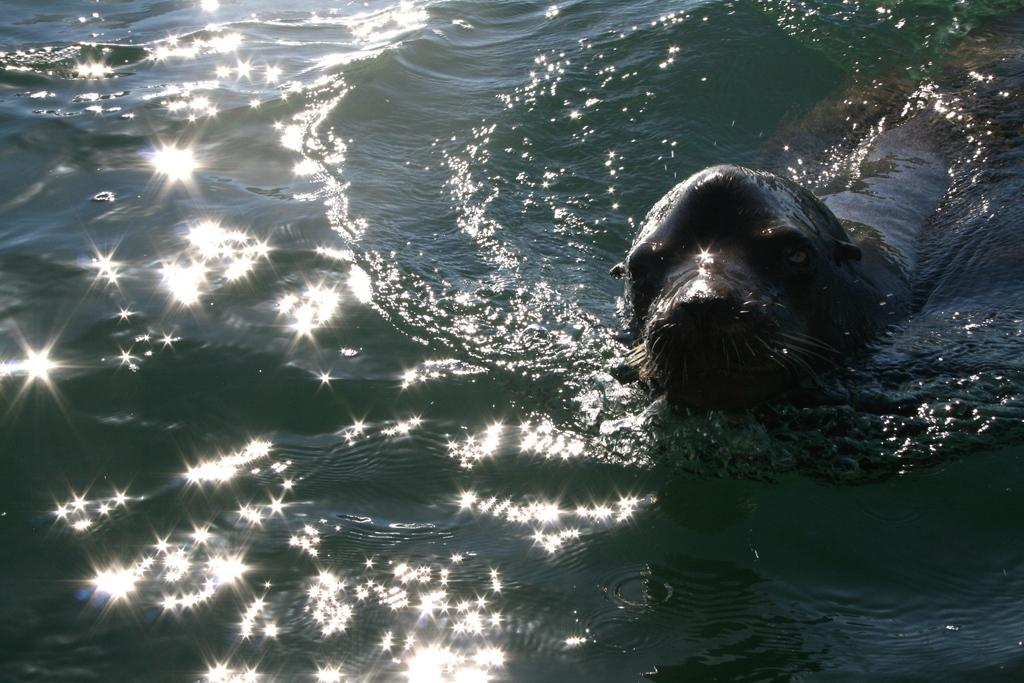What type of animal is in the image? There is a sea animal in the image. What is the environment in which the sea animal is situated? The sea animal is in water. Where is the queen located in the image? There is no queen present in the image; it features a sea animal in water. What type of medical facility can be seen in the image? There is no hospital present in the image; it features a sea animal in water. 